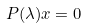Convert formula to latex. <formula><loc_0><loc_0><loc_500><loc_500>P ( \lambda ) x = 0</formula> 